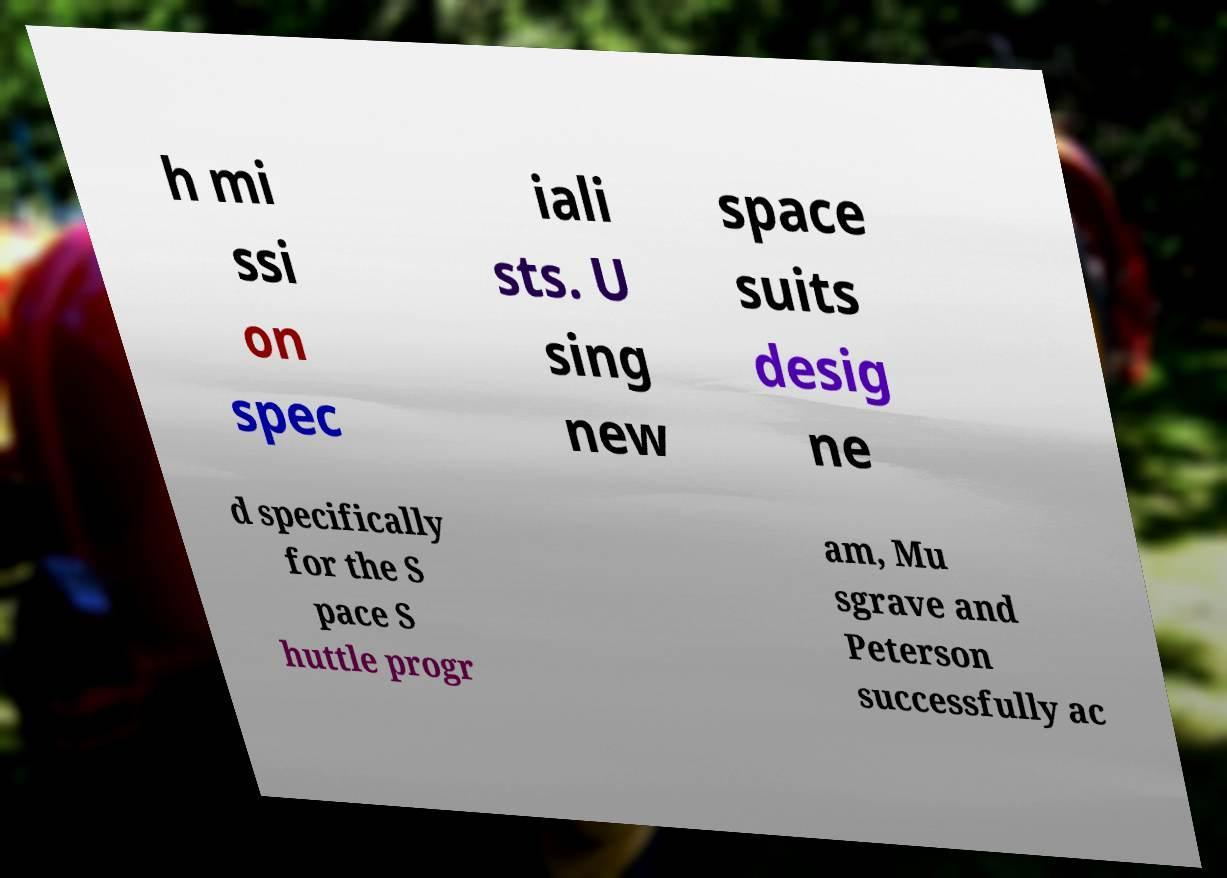Please read and relay the text visible in this image. What does it say? h mi ssi on spec iali sts. U sing new space suits desig ne d specifically for the S pace S huttle progr am, Mu sgrave and Peterson successfully ac 